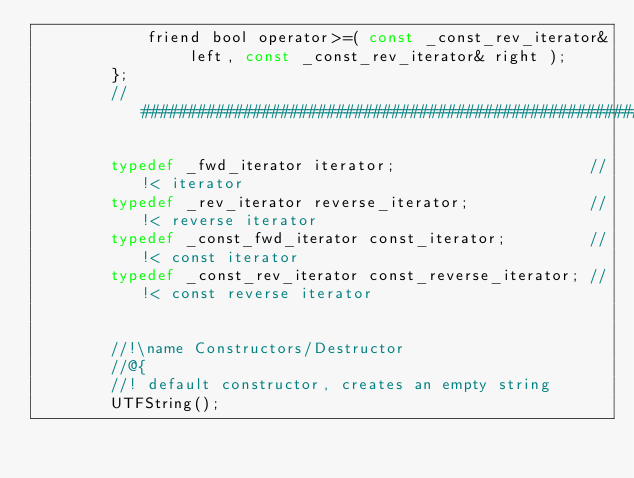<code> <loc_0><loc_0><loc_500><loc_500><_C_>			friend bool operator>=( const _const_rev_iterator& left, const _const_rev_iterator& right );
		};
		//#########################################################################

		typedef _fwd_iterator iterator;                     //!< iterator
		typedef _rev_iterator reverse_iterator;             //!< reverse iterator
		typedef _const_fwd_iterator const_iterator;         //!< const iterator
		typedef _const_rev_iterator const_reverse_iterator; //!< const reverse iterator


		//!\name Constructors/Destructor
		//@{
		//! default constructor, creates an empty string
		UTFString();</code> 